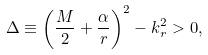Convert formula to latex. <formula><loc_0><loc_0><loc_500><loc_500>\Delta \equiv \left ( \frac { M } { 2 } + \frac { \alpha } { r } \right ) ^ { 2 } - k _ { r } ^ { 2 } > 0 ,</formula> 